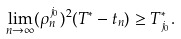Convert formula to latex. <formula><loc_0><loc_0><loc_500><loc_500>\lim _ { n \rightarrow \infty } ( \rho _ { n } ^ { j _ { 0 } } ) ^ { 2 } ( T ^ { * } - t _ { n } ) \geq T _ { j _ { 0 } } ^ { * } .</formula> 